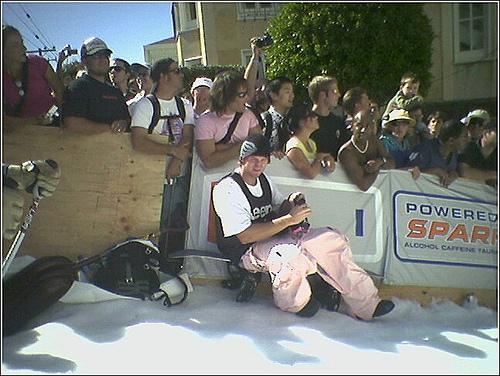Where is this located?
Answer briefly. Outside. How many spectators are watching this event?
Give a very brief answer. 21. What color are the leaves on the tree?
Answer briefly. Green. 